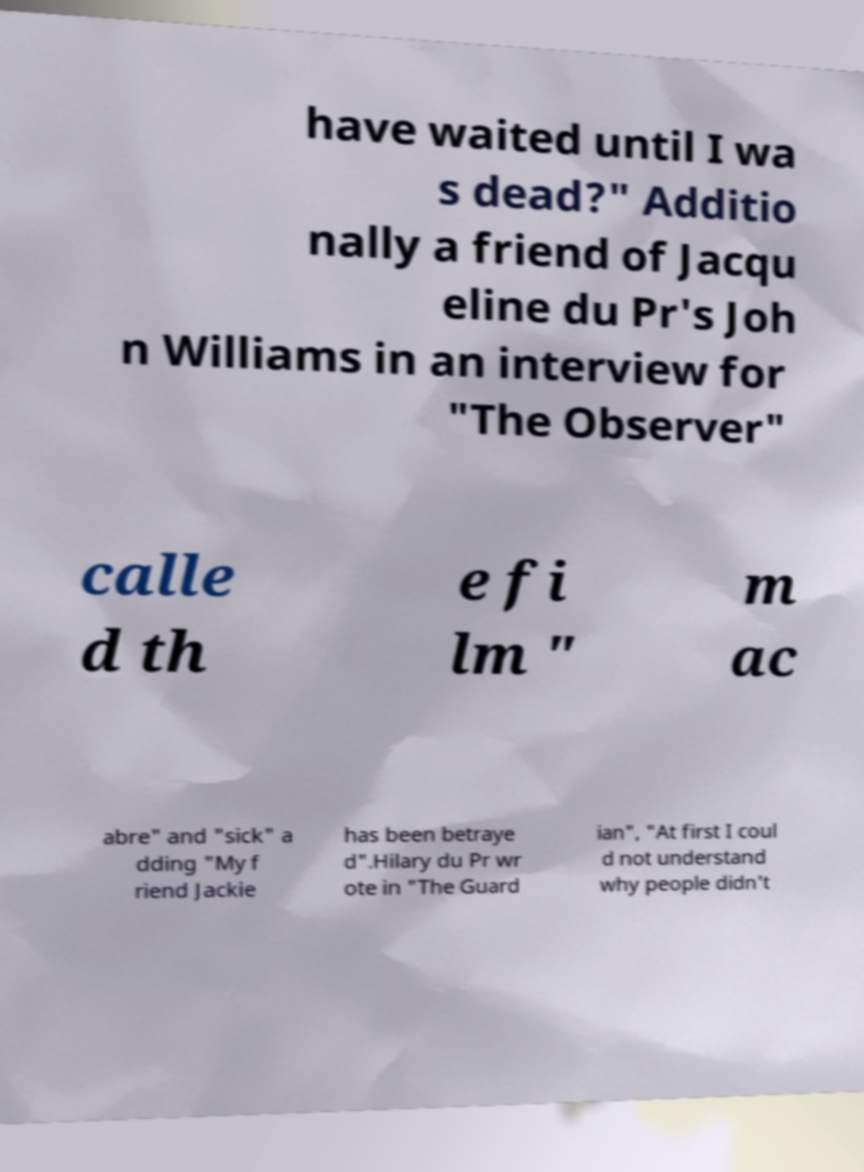I need the written content from this picture converted into text. Can you do that? have waited until I wa s dead?" Additio nally a friend of Jacqu eline du Pr's Joh n Williams in an interview for "The Observer" calle d th e fi lm " m ac abre" and "sick" a dding "My f riend Jackie has been betraye d".Hilary du Pr wr ote in "The Guard ian", "At first I coul d not understand why people didn't 